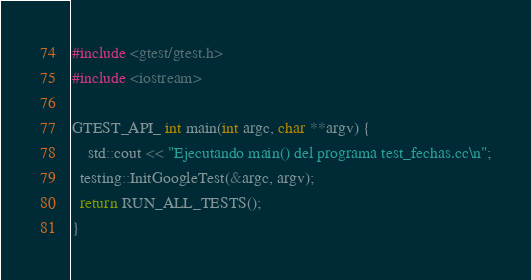Convert code to text. <code><loc_0><loc_0><loc_500><loc_500><_C++_>#include <gtest/gtest.h>
#include <iostream>

GTEST_API_ int main(int argc, char **argv) {
	std::cout << "Ejecutando main() del programa test_fechas.cc\n";
  testing::InitGoogleTest(&argc, argv);
  return RUN_ALL_TESTS();
}
</code> 